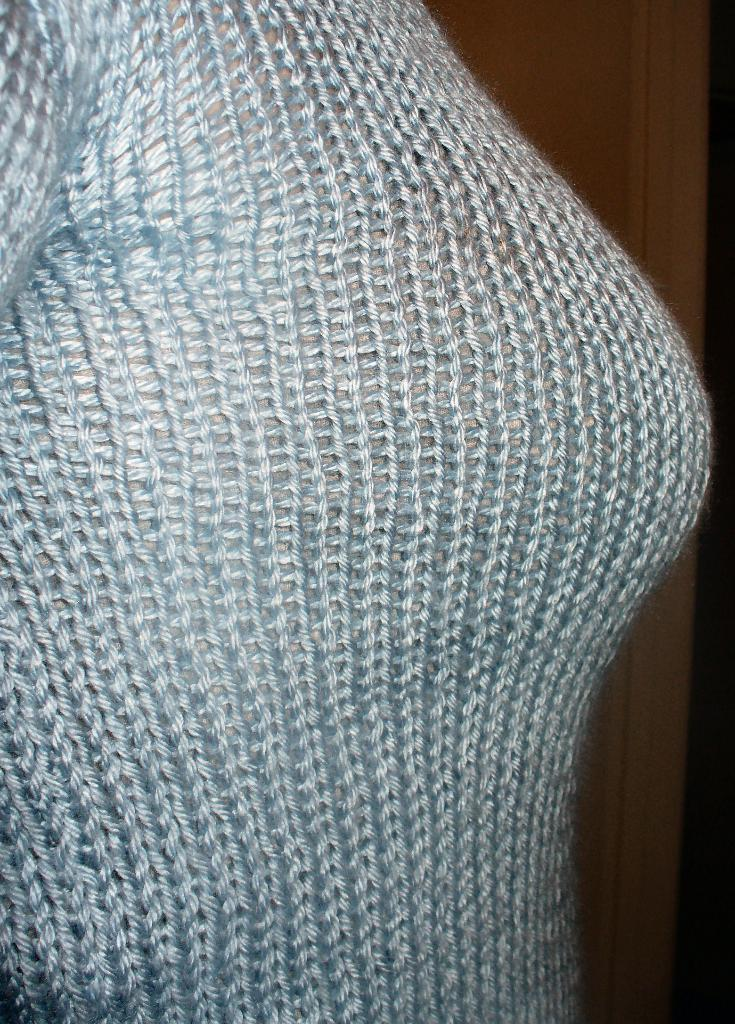Who or what is present in the image? There is a person in the image. What type of clothing is the person wearing? The person is wearing woolen clothes. Can you describe the background of the image? There are objects in the background of the image. What type of heart is visible in the image? There is no heart visible in the image. Is the person wearing a collar in the image? The provided facts do not mention a collar, so we cannot determine if the person is wearing one. 